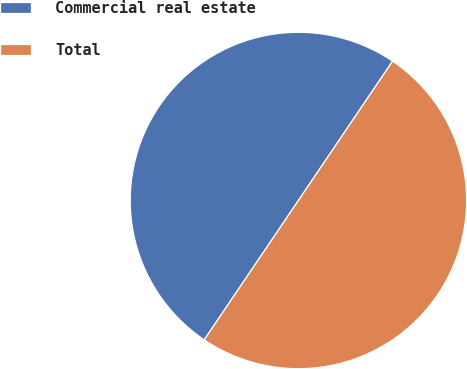<chart> <loc_0><loc_0><loc_500><loc_500><pie_chart><fcel>Commercial real estate<fcel>Total<nl><fcel>50.0%<fcel>50.0%<nl></chart> 